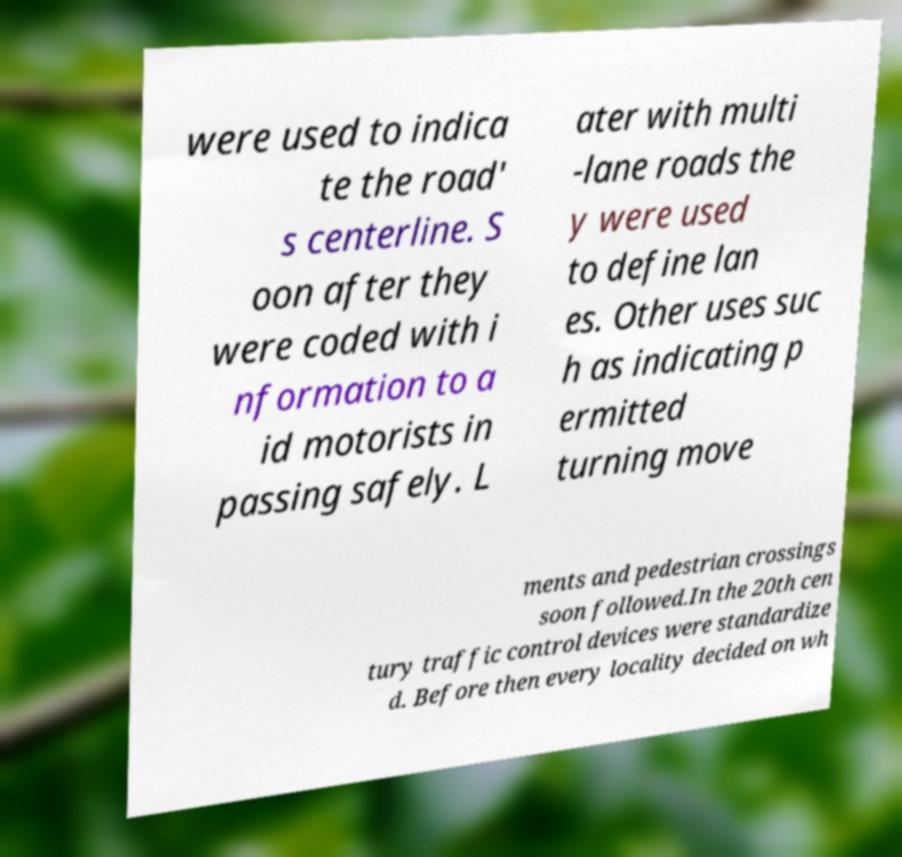Can you accurately transcribe the text from the provided image for me? were used to indica te the road' s centerline. S oon after they were coded with i nformation to a id motorists in passing safely. L ater with multi -lane roads the y were used to define lan es. Other uses suc h as indicating p ermitted turning move ments and pedestrian crossings soon followed.In the 20th cen tury traffic control devices were standardize d. Before then every locality decided on wh 